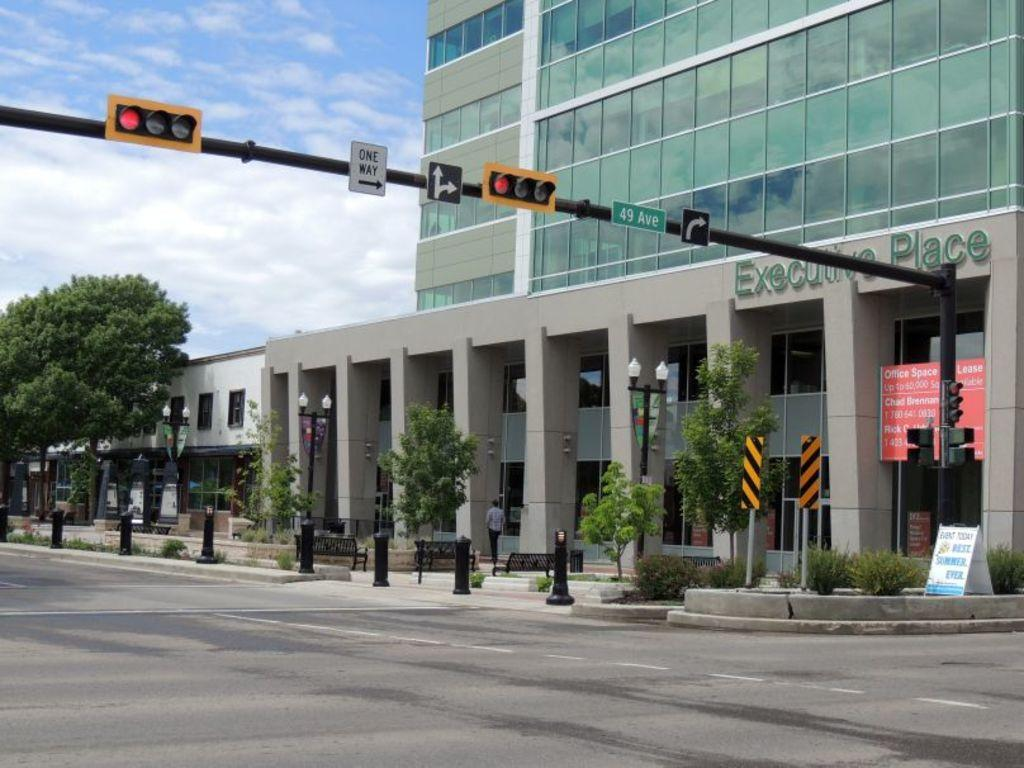Provide a one-sentence caption for the provided image. the street going by the Executive Place is one way. 